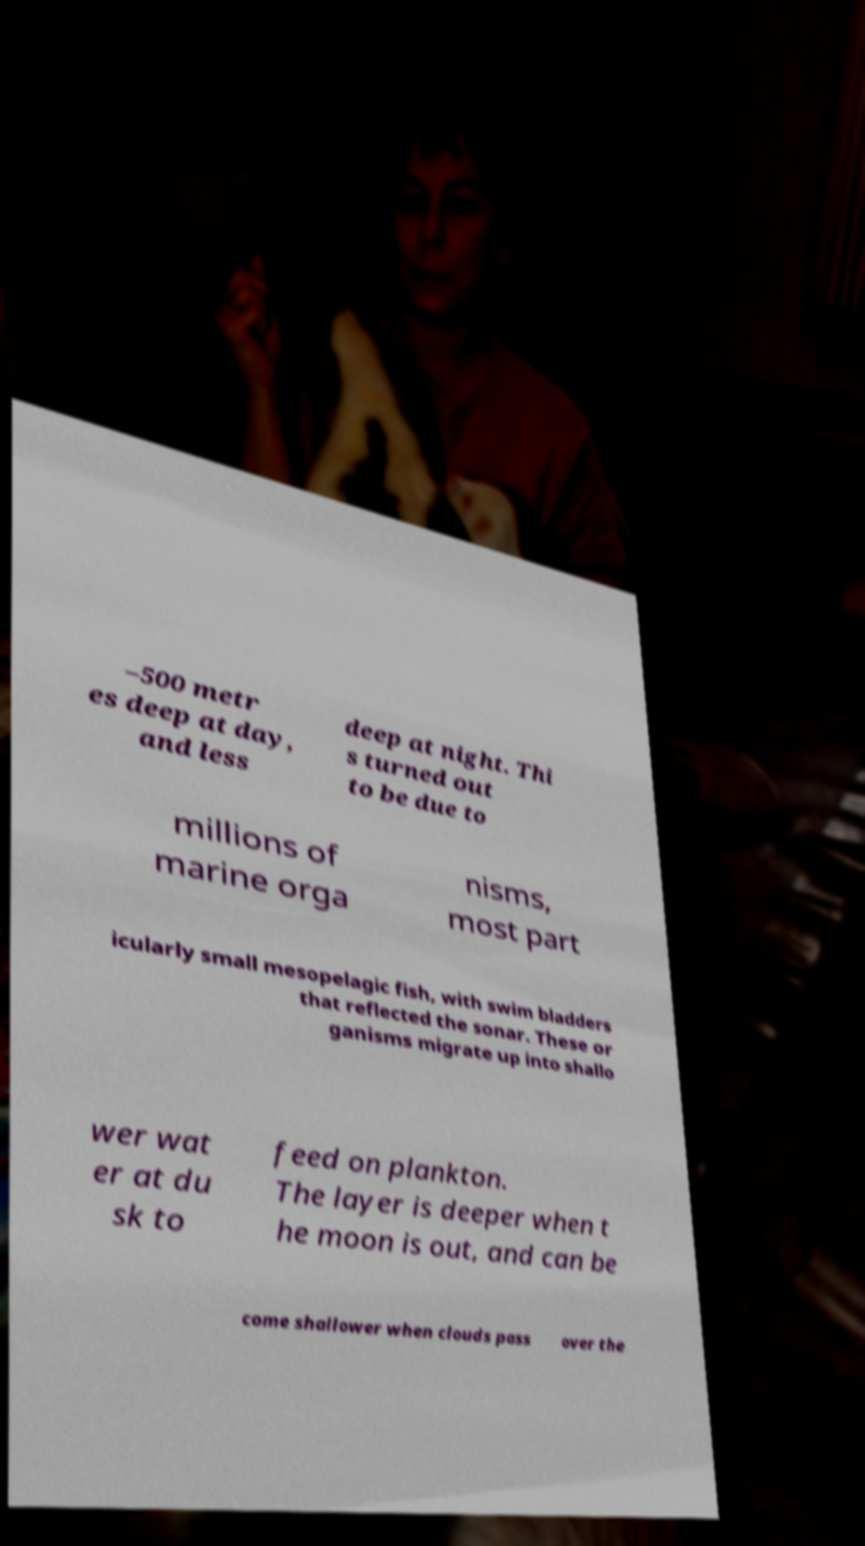Please identify and transcribe the text found in this image. –500 metr es deep at day, and less deep at night. Thi s turned out to be due to millions of marine orga nisms, most part icularly small mesopelagic fish, with swim bladders that reflected the sonar. These or ganisms migrate up into shallo wer wat er at du sk to feed on plankton. The layer is deeper when t he moon is out, and can be come shallower when clouds pass over the 